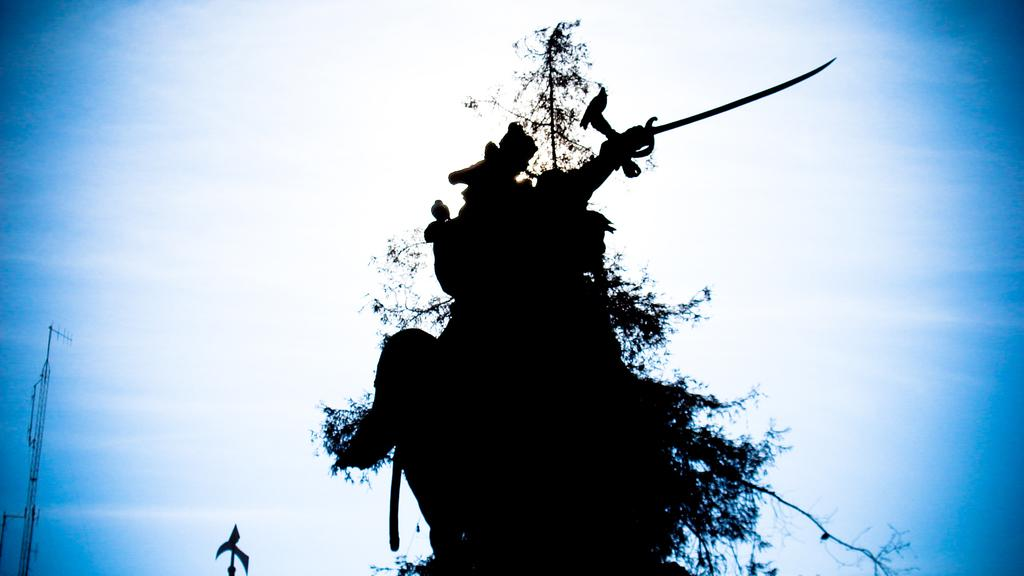What type of image is being described? The image is an art piece. What can be seen in the image? There are birds on a tree in the image. What is visible in the background of the image? There is a tower in the background of the image. What is the condition of the sky in the image? There are clouds in the sky in the image. What is the comparison between the birds and the tower in the image? There is no comparison being made between the birds and the tower in the image; they are simply two separate elements. What is the desire of the birds in the image? There is no indication of the birds having any desires in the image; they are simply depicted as being on a tree. 